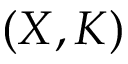Convert formula to latex. <formula><loc_0><loc_0><loc_500><loc_500>( X , K )</formula> 